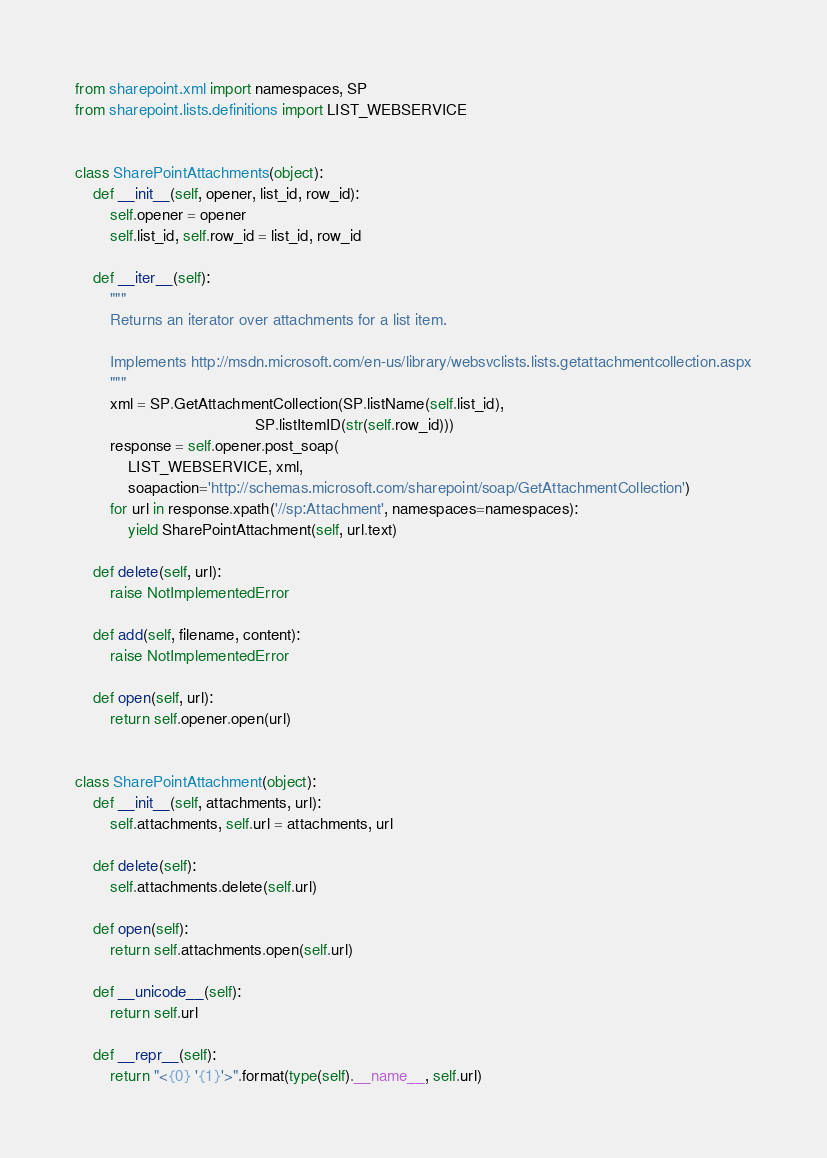<code> <loc_0><loc_0><loc_500><loc_500><_Python_>from sharepoint.xml import namespaces, SP
from sharepoint.lists.definitions import LIST_WEBSERVICE


class SharePointAttachments(object):
    def __init__(self, opener, list_id, row_id):
        self.opener = opener
        self.list_id, self.row_id = list_id, row_id

    def __iter__(self):
        """
        Returns an iterator over attachments for a list item.

        Implements http://msdn.microsoft.com/en-us/library/websvclists.lists.getattachmentcollection.aspx
        """
        xml = SP.GetAttachmentCollection(SP.listName(self.list_id),
                                         SP.listItemID(str(self.row_id)))
        response = self.opener.post_soap(
            LIST_WEBSERVICE, xml,
            soapaction='http://schemas.microsoft.com/sharepoint/soap/GetAttachmentCollection')
        for url in response.xpath('//sp:Attachment', namespaces=namespaces):
            yield SharePointAttachment(self, url.text)

    def delete(self, url):
        raise NotImplementedError

    def add(self, filename, content):
        raise NotImplementedError

    def open(self, url):
        return self.opener.open(url)


class SharePointAttachment(object):
    def __init__(self, attachments, url):
        self.attachments, self.url = attachments, url

    def delete(self):
        self.attachments.delete(self.url)

    def open(self):
        return self.attachments.open(self.url)

    def __unicode__(self):
        return self.url

    def __repr__(self):
        return "<{0} '{1}'>".format(type(self).__name__, self.url)

</code> 